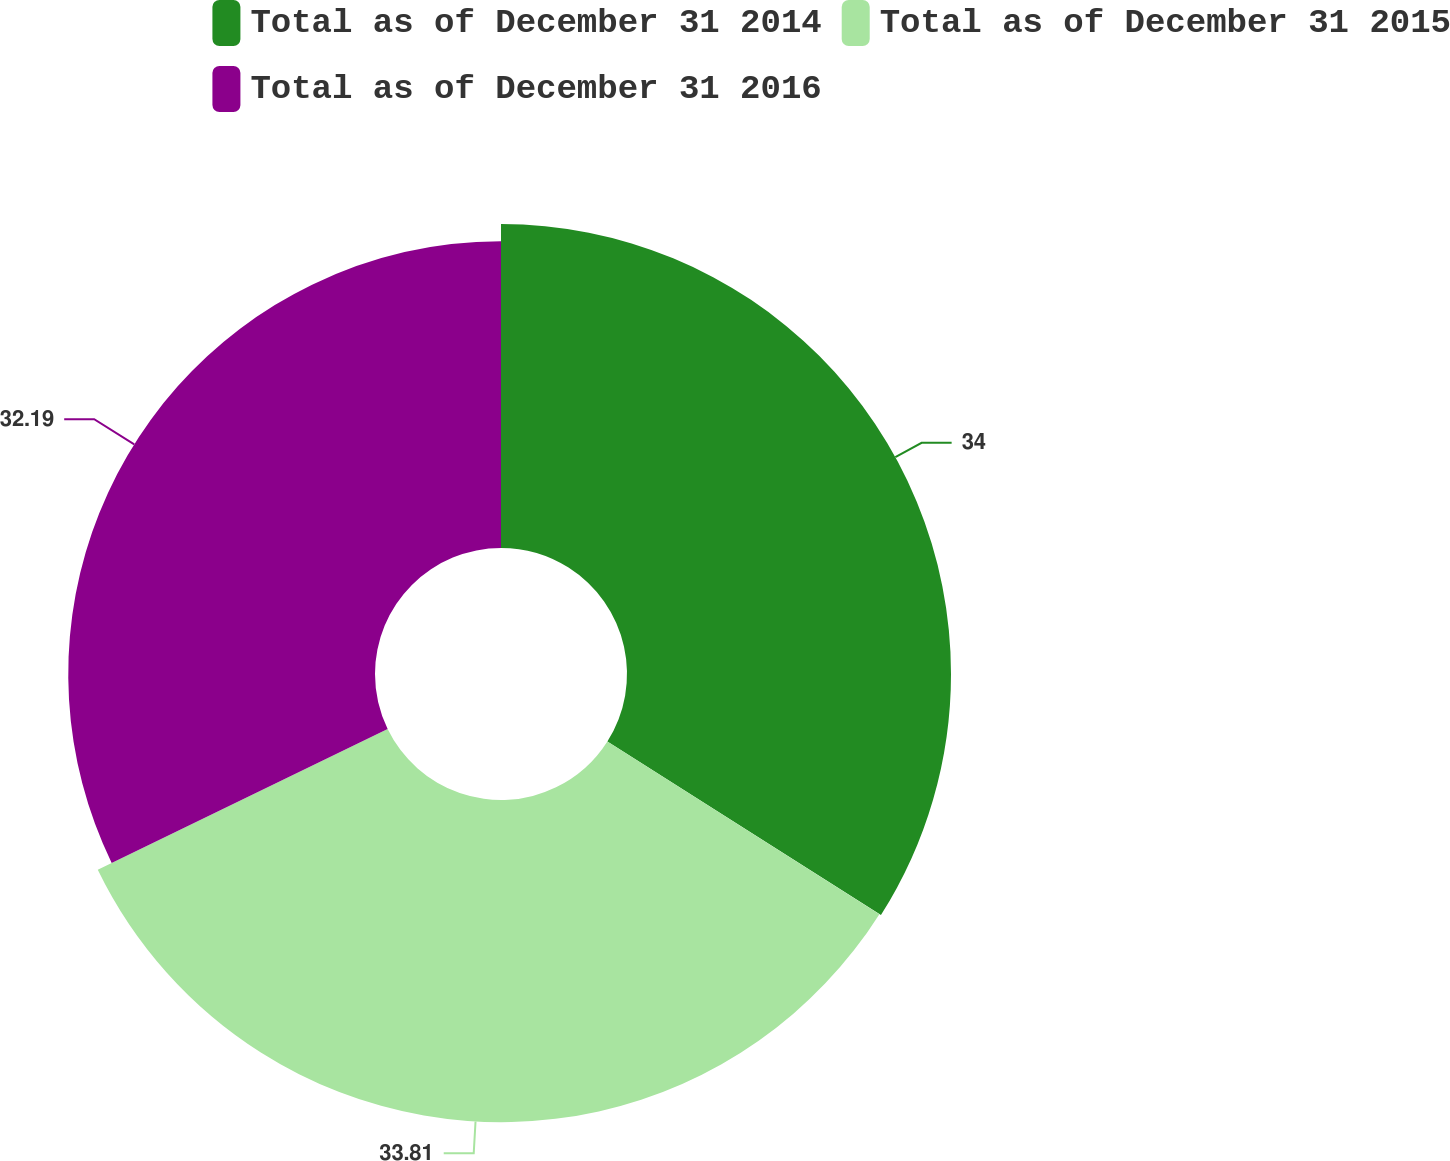Convert chart. <chart><loc_0><loc_0><loc_500><loc_500><pie_chart><fcel>Total as of December 31 2014<fcel>Total as of December 31 2015<fcel>Total as of December 31 2016<nl><fcel>34.0%<fcel>33.81%<fcel>32.19%<nl></chart> 